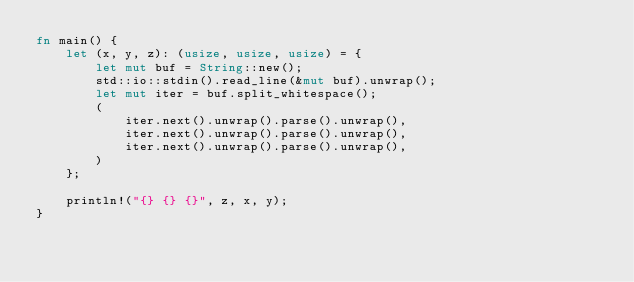<code> <loc_0><loc_0><loc_500><loc_500><_Rust_>fn main() {
    let (x, y, z): (usize, usize, usize) = {
        let mut buf = String::new();
        std::io::stdin().read_line(&mut buf).unwrap();
        let mut iter = buf.split_whitespace();
        (
            iter.next().unwrap().parse().unwrap(),
            iter.next().unwrap().parse().unwrap(),
            iter.next().unwrap().parse().unwrap(),
        )
    };

    println!("{} {} {}", z, x, y);
}</code> 